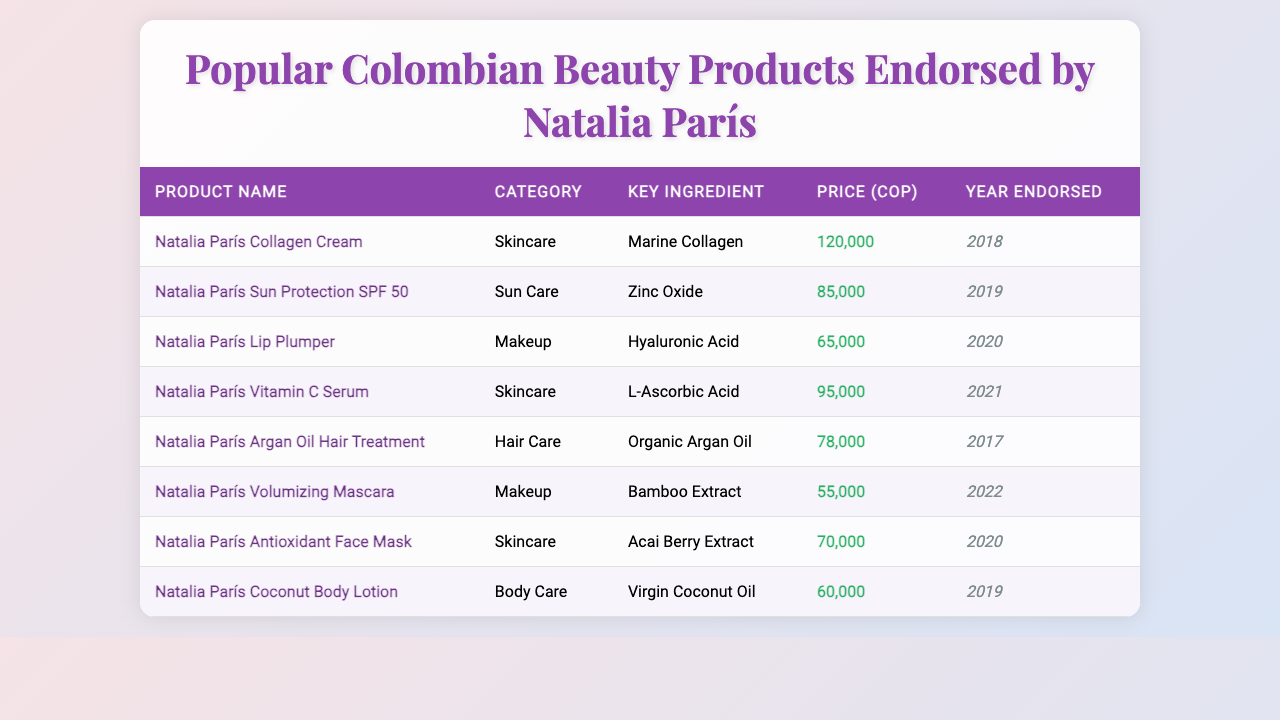What is the highest-priced beauty product endorsed by Natalia París? By inspecting the price column in the table, I can see that the highest price listed is for "Natalia París Collagen Cream" at 120,000 COP.
Answer: 120,000 COP How many beauty products were endorsed by Natalia París in total? Counting the number of rows in the table shows there are 8 products listed.
Answer: 8 Which product has the key ingredient "Zinc Oxide"? By looking through the key ingredient column, I find "Zinc Oxide" is associated with "Natalia París Sun Protection SPF 50."
Answer: Natalia París Sun Protection SPF 50 What is the average price of the beauty products? First, I sum the prices (120,000 + 85,000 + 65,000 + 95,000 + 78,000 + 55,000 + 70,000 + 60,000 = 738,000). There are 8 products, thus the average price is 738,000 / 8 = 92,250.
Answer: 92,250 COP Which category has the fewest products endorsed by Natalia París? Examining each category, both "Body Care" and "Makeup" have 2 products; "Hair Care" has 1; "Sun Care" has 1, and "Skincare" has 3. Clearly, "Body Care" and "Makeup" tie for the fewest.
Answer: Body Care or Makeup Is the "Natalia París Lip Plumper" endorsed in 2020? Checking the Year Endorsed column, "Natalia París Lip Plumper" is definitively marked as endorsed in 2020, confirming the statement is true.
Answer: Yes What is the price difference between the "Natalia París Vitamin C Serum" and the "Natalia París Lip Plumper"? The price of "Natalia París Vitamin C Serum" is 95,000 COP and "Natalia París Lip Plumper" is 65,000 COP. The difference is 95,000 - 65,000 = 30,000 COP.
Answer: 30,000 COP Can you identify if "Organic Argan Oil" is used in more than one product? Looking through the key ingredient column, I see "Organic Argan Oil" is only listed under "Natalia París Argan Oil Hair Treatment," confirming it is used in just one product.
Answer: No What year was the "Natalia París Volumizing Mascara" endorsed? By checking the table, it's clearly stated that "Natalia París Volumizing Mascara" was endorsed in 2022.
Answer: 2022 Which product belongs to the "Skincare" category and has "Acai Berry Extract" as its key ingredient? Referring to the table, "Natalia París Antioxidant Face Mask" in the "Skincare" category has "Acai Berry Extract" listed as its key ingredient.
Answer: Natalia París Antioxidant Face Mask 